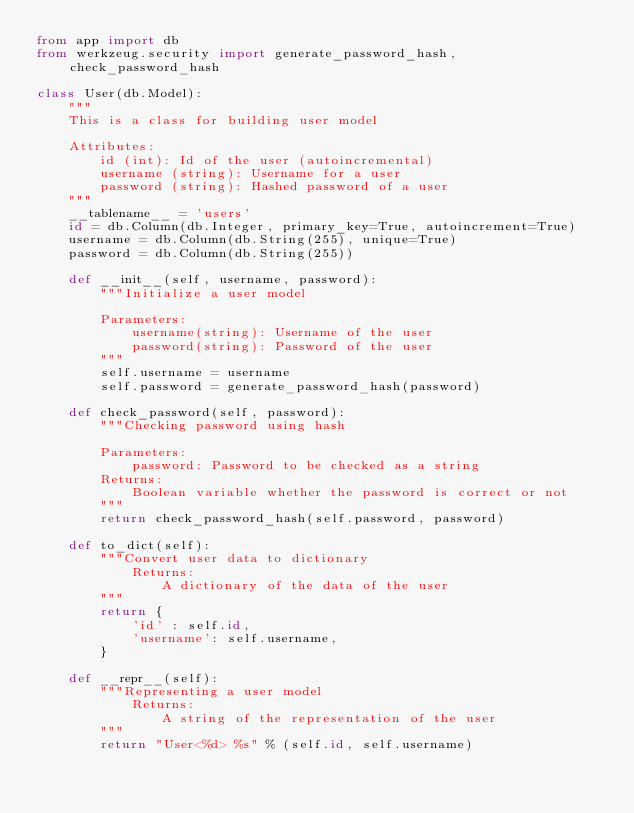Convert code to text. <code><loc_0><loc_0><loc_500><loc_500><_Python_>from app import db
from werkzeug.security import generate_password_hash, check_password_hash

class User(db.Model):
    """
    This is a class for building user model

    Attributes:
        id (int): Id of the user (autoincremental)
        username (string): Username for a user
        password (string): Hashed password of a user
    """
    __tablename__ = 'users'
    id = db.Column(db.Integer, primary_key=True, autoincrement=True)
    username = db.Column(db.String(255), unique=True)
    password = db.Column(db.String(255))

    def __init__(self, username, password):
        """Initialize a user model

        Parameters:
            username(string): Username of the user
            password(string): Password of the user
        """
        self.username = username
        self.password = generate_password_hash(password)

    def check_password(self, password):
        """Checking password using hash

        Parameters:
            password: Password to be checked as a string
        Returns:
            Boolean variable whether the password is correct or not
        """
        return check_password_hash(self.password, password)

    def to_dict(self):
        """Convert user data to dictionary
            Returns:
                A dictionary of the data of the user
        """
        return {
            'id' : self.id,
            'username': self.username,
        }

    def __repr__(self):
        """Representing a user model
            Returns:
                A string of the representation of the user
        """
        return "User<%d> %s" % (self.id, self.username)
</code> 